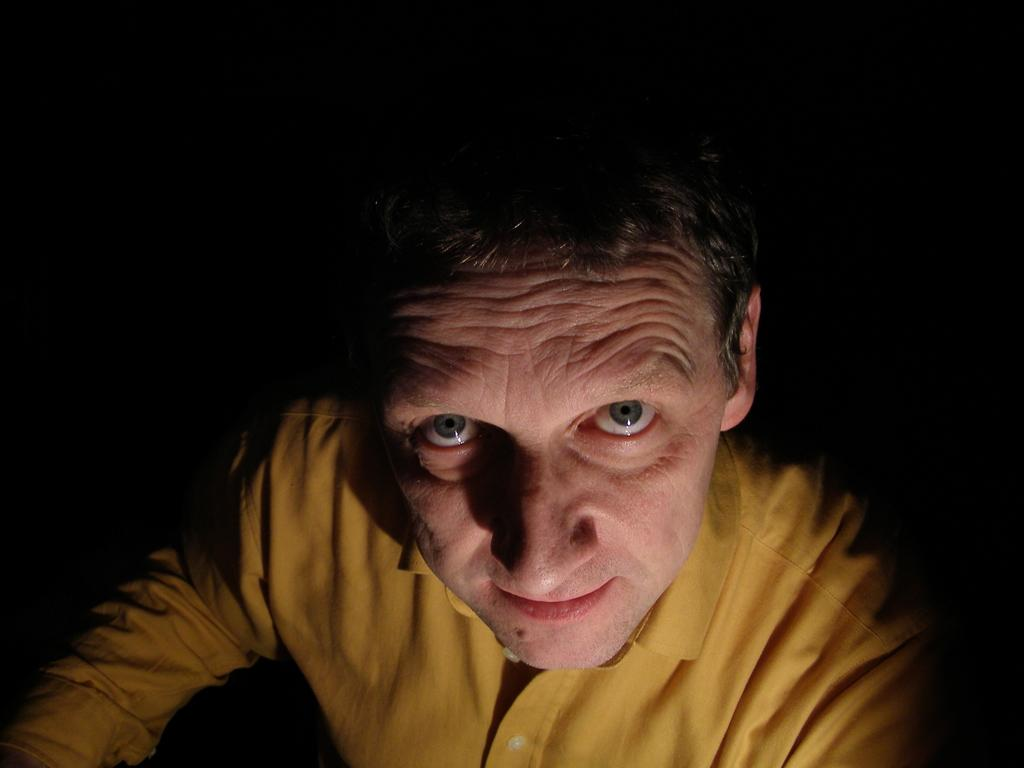Who is the main subject in the image? There is a man in the image. What is the man wearing in the image? The man is wearing a yellow shirt. Can you describe the background of the image? The background of the image is dark. How many sisters does the man have in the image? There is no information about the man's sisters in the image. What emotion is the man displaying in the image? The image does not show any clear indication of the man's emotions. 